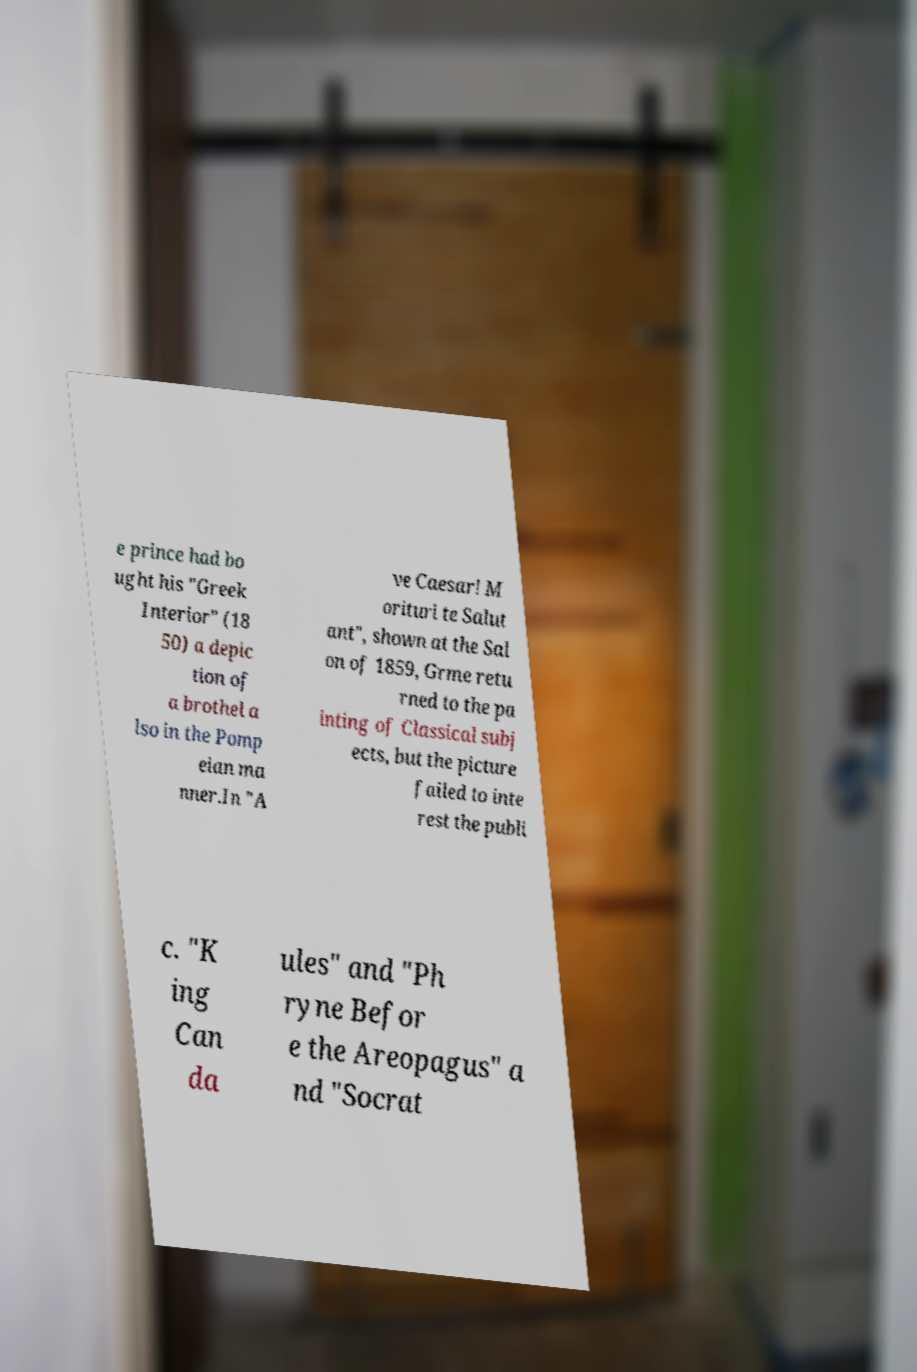Please identify and transcribe the text found in this image. e prince had bo ught his "Greek Interior" (18 50) a depic tion of a brothel a lso in the Pomp eian ma nner.In "A ve Caesar! M orituri te Salut ant", shown at the Sal on of 1859, Grme retu rned to the pa inting of Classical subj ects, but the picture failed to inte rest the publi c. "K ing Can da ules" and "Ph ryne Befor e the Areopagus" a nd "Socrat 